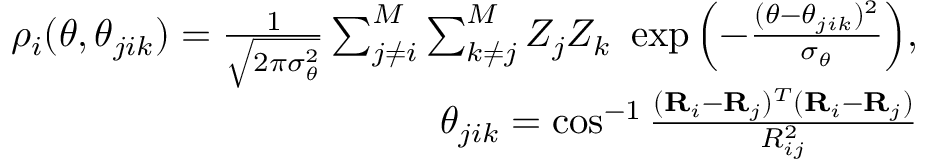Convert formula to latex. <formula><loc_0><loc_0><loc_500><loc_500>\begin{array} { r } { \rho _ { i } ( \theta , \theta _ { j i k } ) = \frac { 1 } { \sqrt { 2 \pi \sigma _ { \theta } ^ { 2 } } } \sum _ { j \neq i } ^ { M } \sum _ { k \neq j } ^ { M } Z _ { j } Z _ { k } \exp { \left ( - \frac { ( \theta - \theta _ { j i k } ) ^ { 2 } } { \sigma _ { \theta } } \right ) } , } \\ { \theta _ { j i k } = \cos ^ { - 1 } \frac { ( R _ { i } - R _ { j } ) ^ { T } ( R _ { i } - R _ { j } ) } { R _ { i j } ^ { 2 } } } \end{array}</formula> 